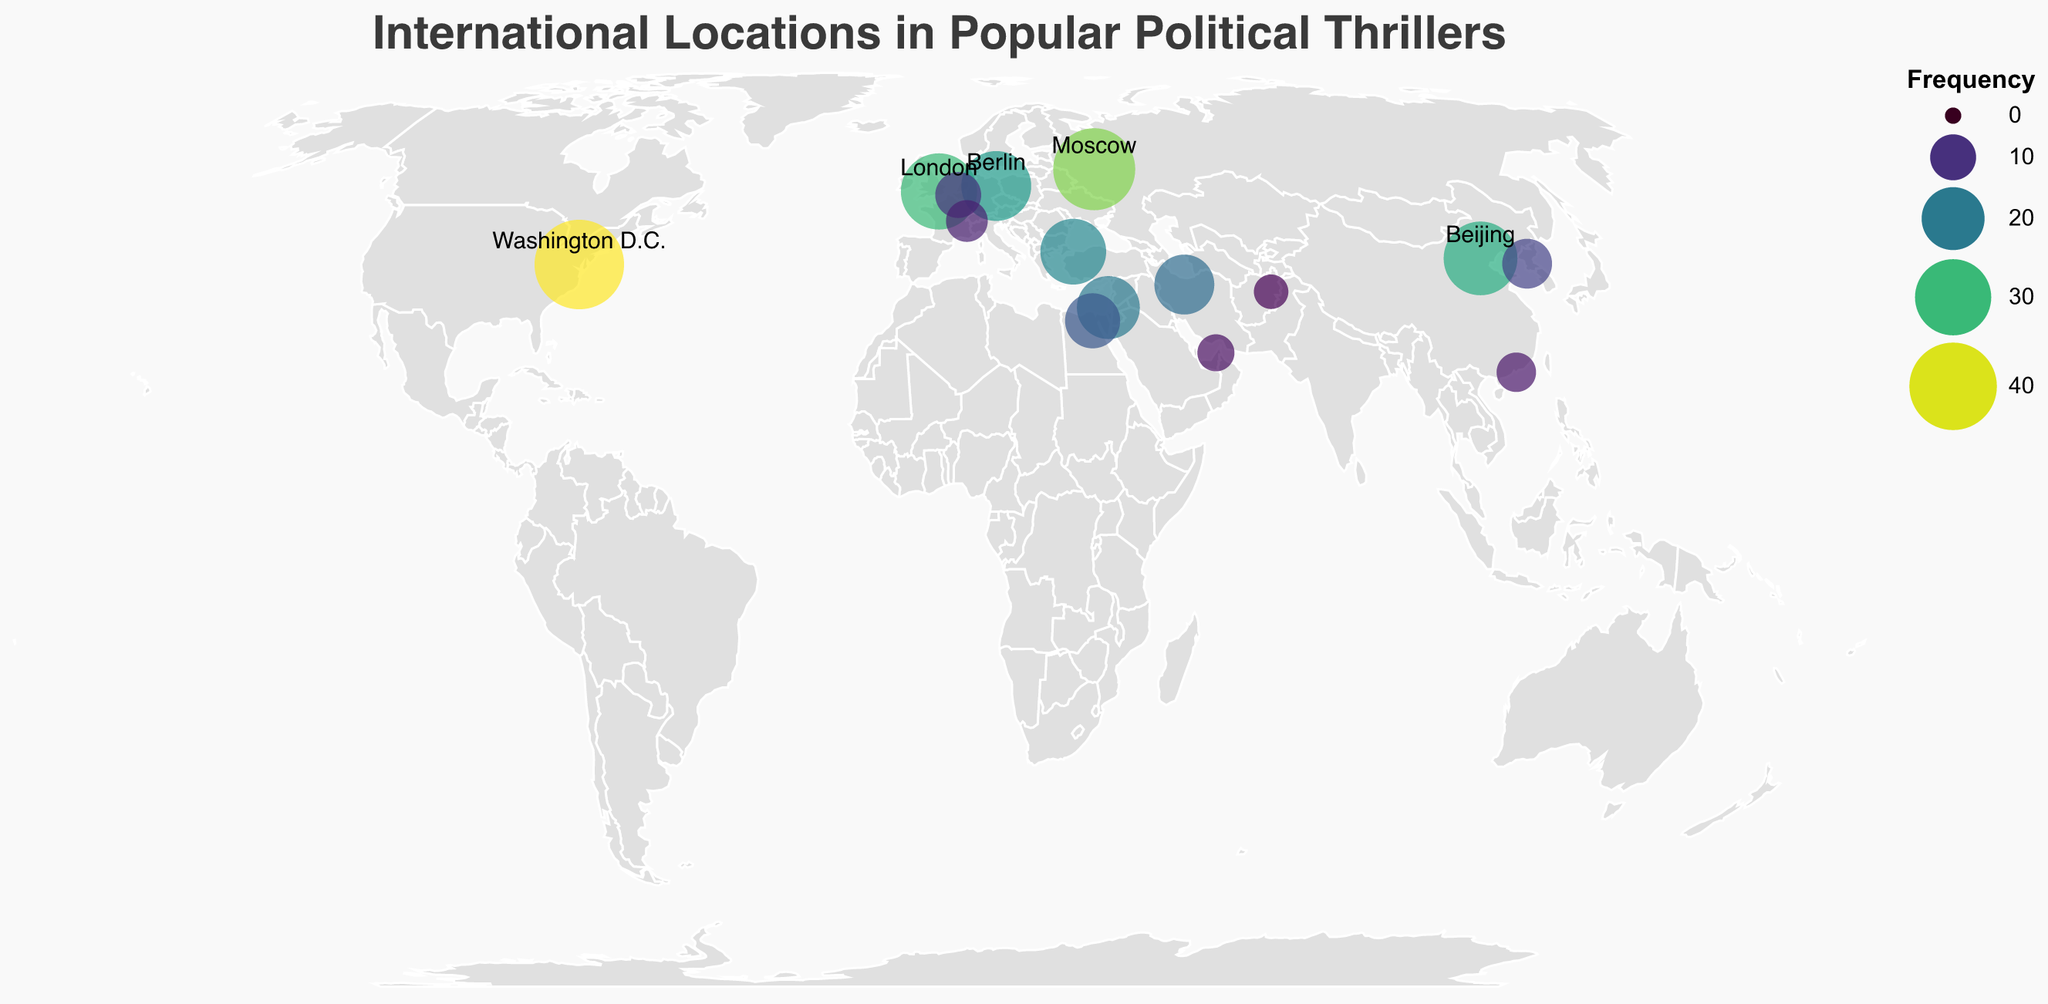What is the title of the figure? The title is usually displayed prominently at the top and it reads "International Locations in Popular Political Thrillers".
Answer: International Locations in Popular Political Thrillers Which city appears most frequently in political thrillers? The largest circle, which is also darker in color, represents the most frequently appearing city, which is Washington D.C.
Answer: Washington D.C Which city has a frequency closest to 30? Look for a city with a medium-sized circle and color shade near 30. This is London.
Answer: London How many cities have a frequency of less than 10? Look for all circles smaller and lighter in color directly and count them, which are Brussels, Geneva, Hong Kong, Dubai, and Kabul. There are 5 such cities.
Answer: 5 Name three cities that appear more frequently than Berlin but less frequently than Washington D.C. Look for cities with circle sizes and colors between that of Berlin and Washington D.C. These cities are Moscow, London, and Beijing, based on their circle sizes and colors.
Answer: Moscow, London, Beijing Which cities have a frequency between 5 and 15? Identify the cities where the circle sizes and colors indicate a frequency within this range. These are Cairo, Pyongyang, Brussels, Geneva, Hong Kong, and Dubai.
Answer: Cairo, Pyongyang, Brussels, Geneva, Hong Kong, Dubai What is the combined frequency of London, Berlin, and Istanbul? Add the frequencies of these three cities: 30 (London) + 25 (Berlin) + 22 (Istanbul) = 77.
Answer: 77 Is Moscow featured more or less frequently than Beijing? Compare circle sizes and colors for Moscow and Beijing. Moscow's circle is larger and darker. Hence, Moscow features more frequently than Beijing.
Answer: More frequently Which location shown on the map is featured least often in political thrillers? The smallest and lightest circle represents the least frequent location, which is Kabul.
Answer: Kabul How many locations are specifically labeled by name on the map? Count the text labels on the map for specific cities. There are five labeled locations: Washington D.C., Moscow, London, Beijing, and Berlin.
Answer: 5 